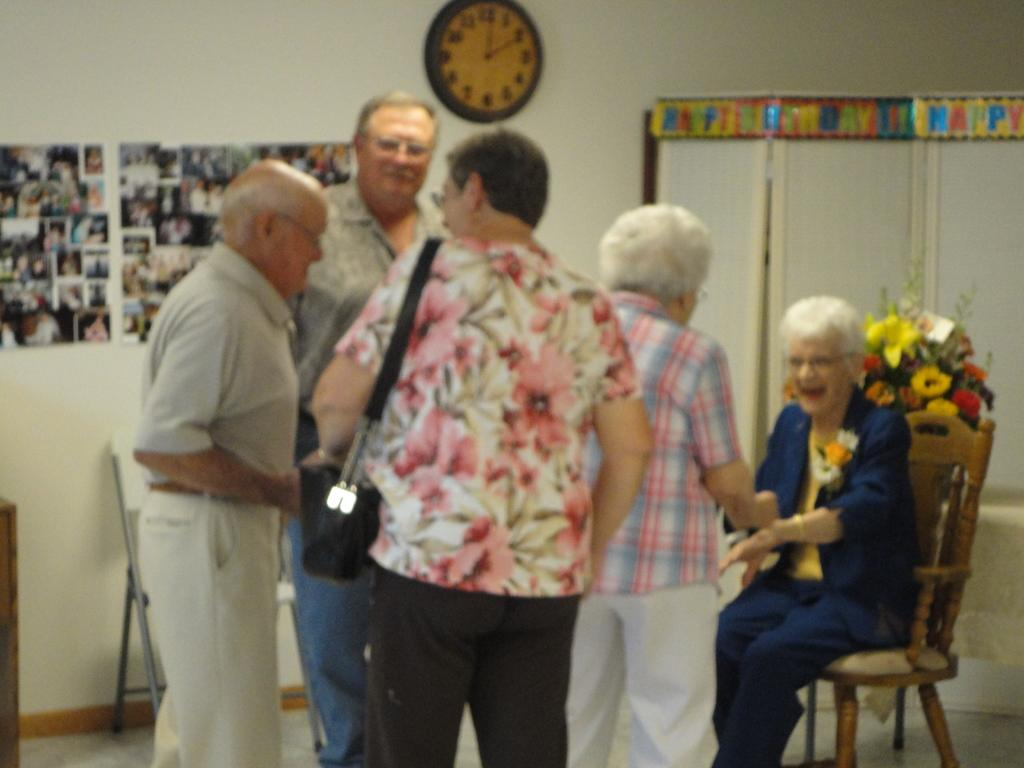<image>
Share a concise interpretation of the image provided. A collection of old people in front of decorations that say Happy Birthday. 